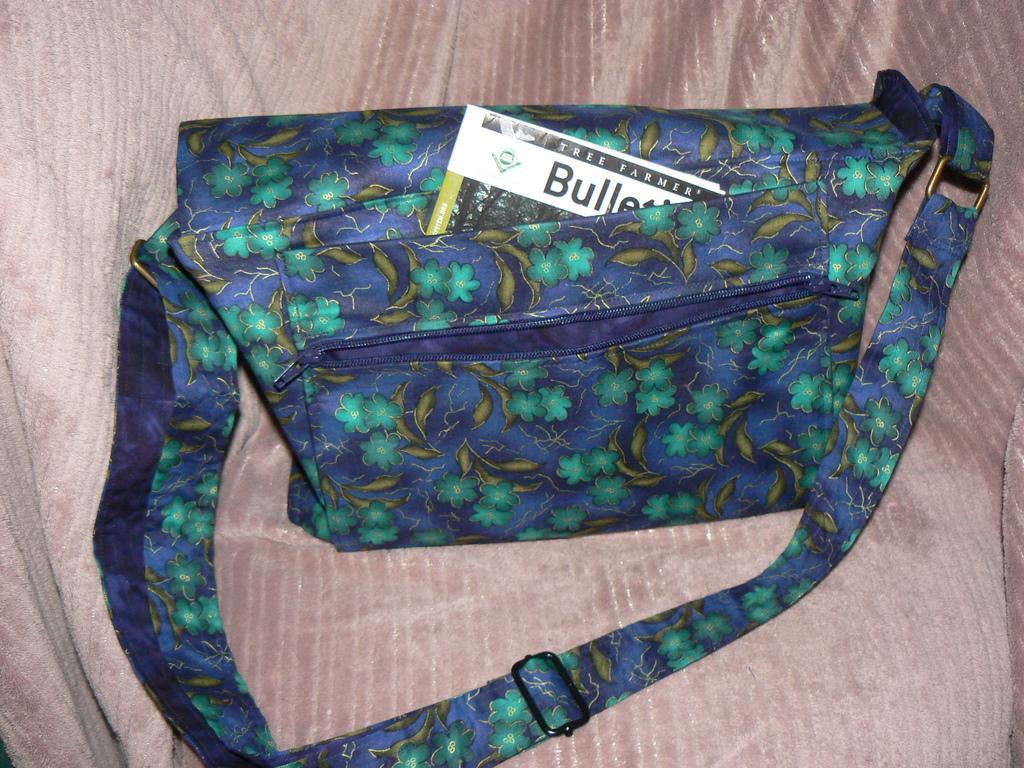Please provide a concise description of this image. This is a blue handbag with green flowers design on it and the background is pink in color. 